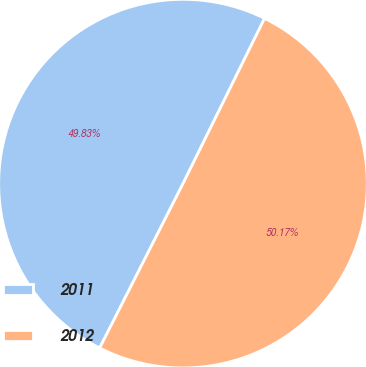<chart> <loc_0><loc_0><loc_500><loc_500><pie_chart><fcel>2011<fcel>2012<nl><fcel>49.83%<fcel>50.17%<nl></chart> 